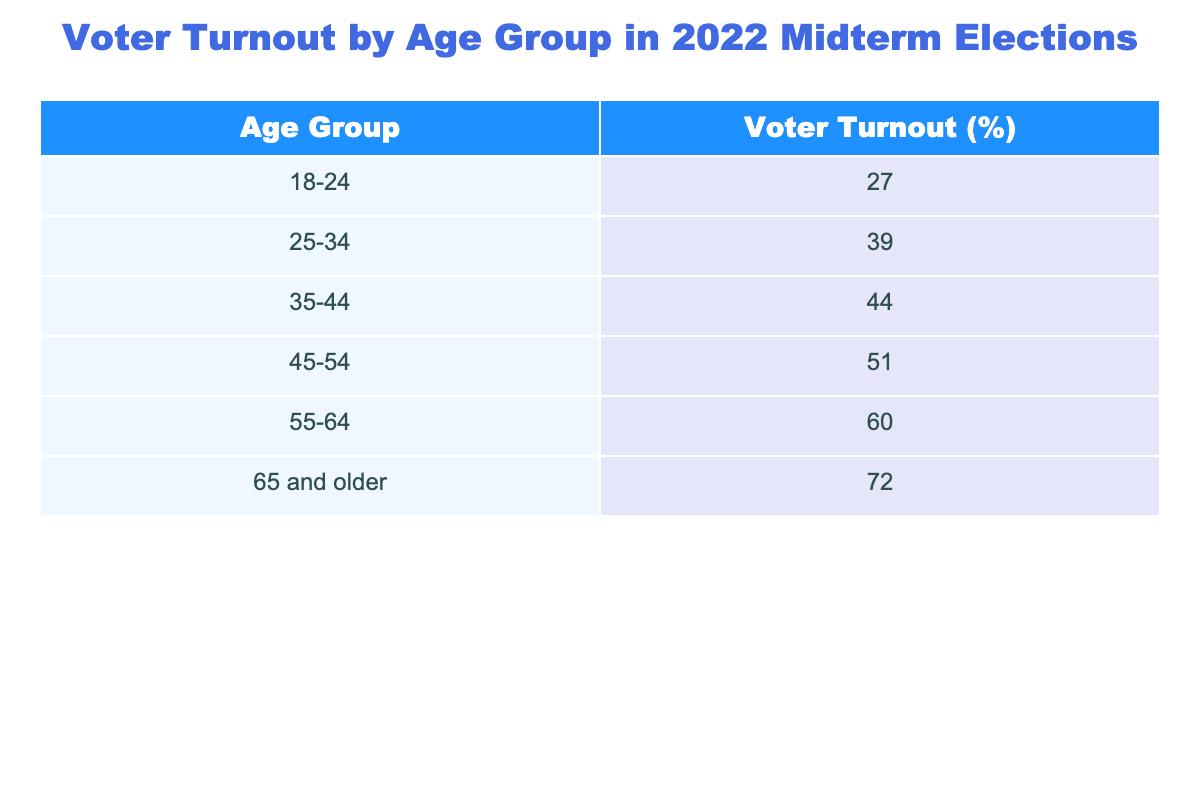What is the voter turnout percentage for the 18-24 age group? The table shows that the voter turnout percentage for the 18-24 age group is 27%.
Answer: 27% What age group has the highest voter turnout? The 65 and older age group has the highest voter turnout at 72%.
Answer: 65 and older Which age group has a voter turnout percentage of 51%? According to the table, the 45-54 age group has a voter turnout percentage of 51%.
Answer: 45-54 What is the difference in voter turnout between the 55-64 and 35-44 age groups? The voter turnout for the 55-64 age group is 60% and for the 35-44 age group, it is 44%. The difference is 60% - 44% = 16%.
Answer: 16% What is the average voter turnout across all age groups listed? To calculate the average, add all the turnout percentages (27 + 39 + 44 + 51 + 60 + 72 = 293) and divide by the number of groups (6). The average is 293 / 6 = 48.83%.
Answer: 48.83% Is the voter turnout for the 25-34 age group above 40%? The table indicates that the voter turnout for the 25-34 age group is 39%, which is not above 40%.
Answer: No Which age group has a voter turnout percentage below the overall average? The average voter turnout is 48.83%. The age group 18-24 has a turnout of 27%, and the 25-34 age group has a turnout of 39%, both of which are below the average.
Answer: 18-24 and 25-34 If we combine the turnout percentages of the 18-24 and 25-34 age groups, what is the total? The turnout for the 18-24 age group is 27% and for the 25-34 age group is 39%. The total is 27% + 39% = 66%.
Answer: 66% What percentage of voters aged 65 and older participated in the election compared to those aged 18-24? The turnout for those aged 65 and older is 72%, while for 18-24 it's 27%. The percentage of older voters is significantly higher: 72% - 27% = 45% more.
Answer: 45% more How does the voter turnout of the 45-54 age group compare with the 55-64 age group? The voter turnout for the 45-54 age group is 51%, and for the 55-64 age group, it is 60%. Thus, the 55-64 group has 9% higher turnout than the 45-54 group.
Answer: 9% higher 